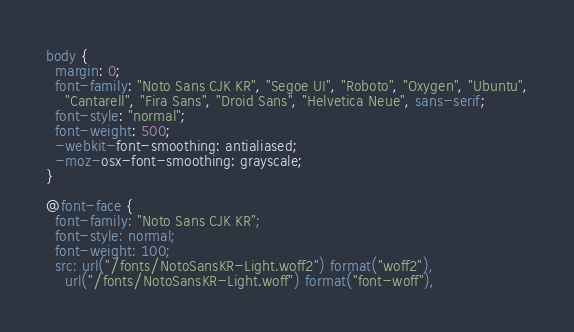Convert code to text. <code><loc_0><loc_0><loc_500><loc_500><_CSS_>body {
  margin: 0;
  font-family: "Noto Sans CJK KR", "Segoe UI", "Roboto", "Oxygen", "Ubuntu",
    "Cantarell", "Fira Sans", "Droid Sans", "Helvetica Neue", sans-serif;
  font-style: "normal";
  font-weight: 500;
  -webkit-font-smoothing: antialiased;
  -moz-osx-font-smoothing: grayscale;
}

@font-face {
  font-family: "Noto Sans CJK KR";
  font-style: normal;
  font-weight: 100;
  src: url("/fonts/NotoSansKR-Light.woff2") format("woff2"),
    url("/fonts/NotoSansKR-Light.woff") format("font-woff"),</code> 